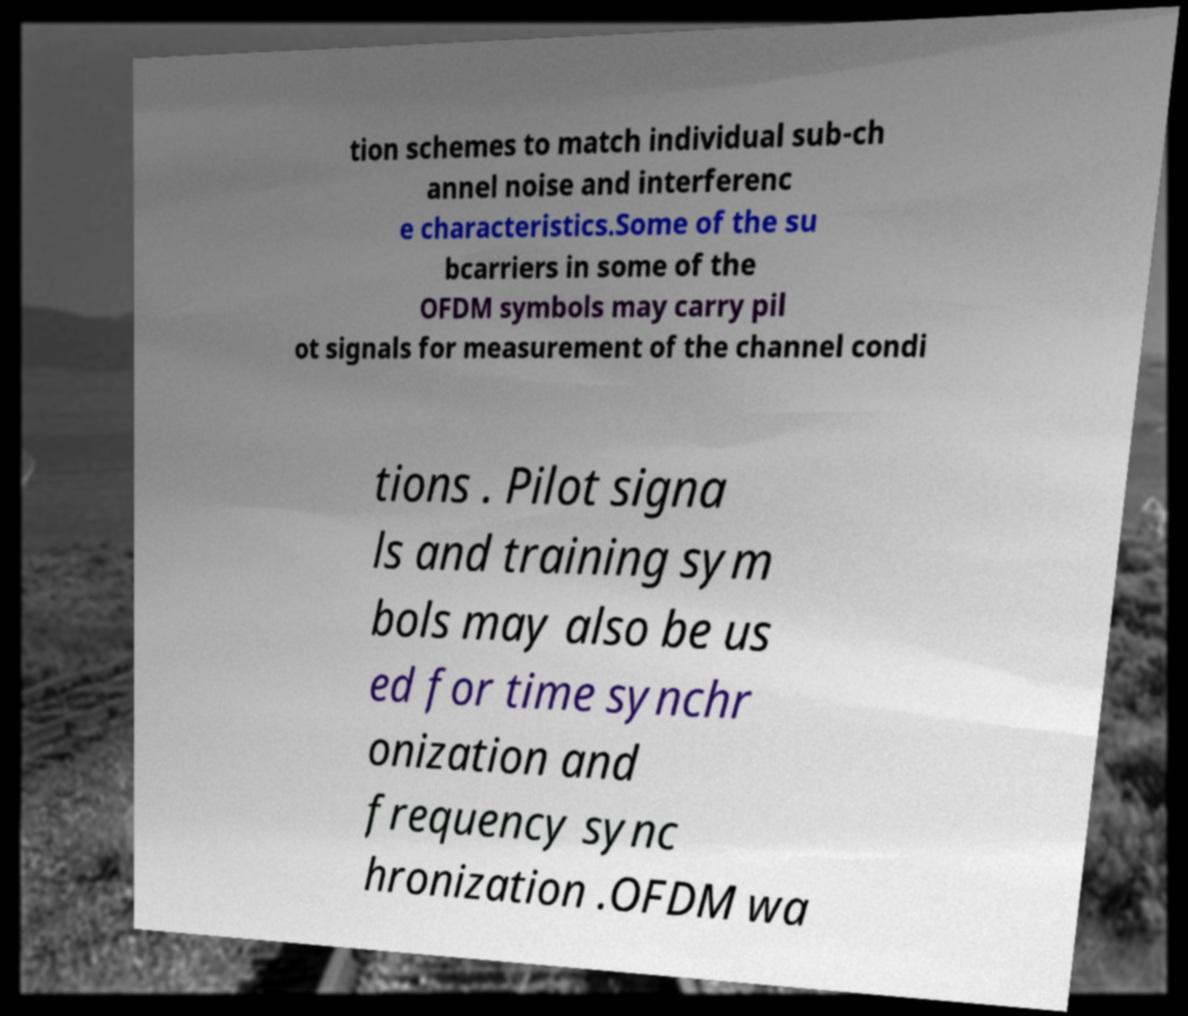Could you assist in decoding the text presented in this image and type it out clearly? tion schemes to match individual sub-ch annel noise and interferenc e characteristics.Some of the su bcarriers in some of the OFDM symbols may carry pil ot signals for measurement of the channel condi tions . Pilot signa ls and training sym bols may also be us ed for time synchr onization and frequency sync hronization .OFDM wa 